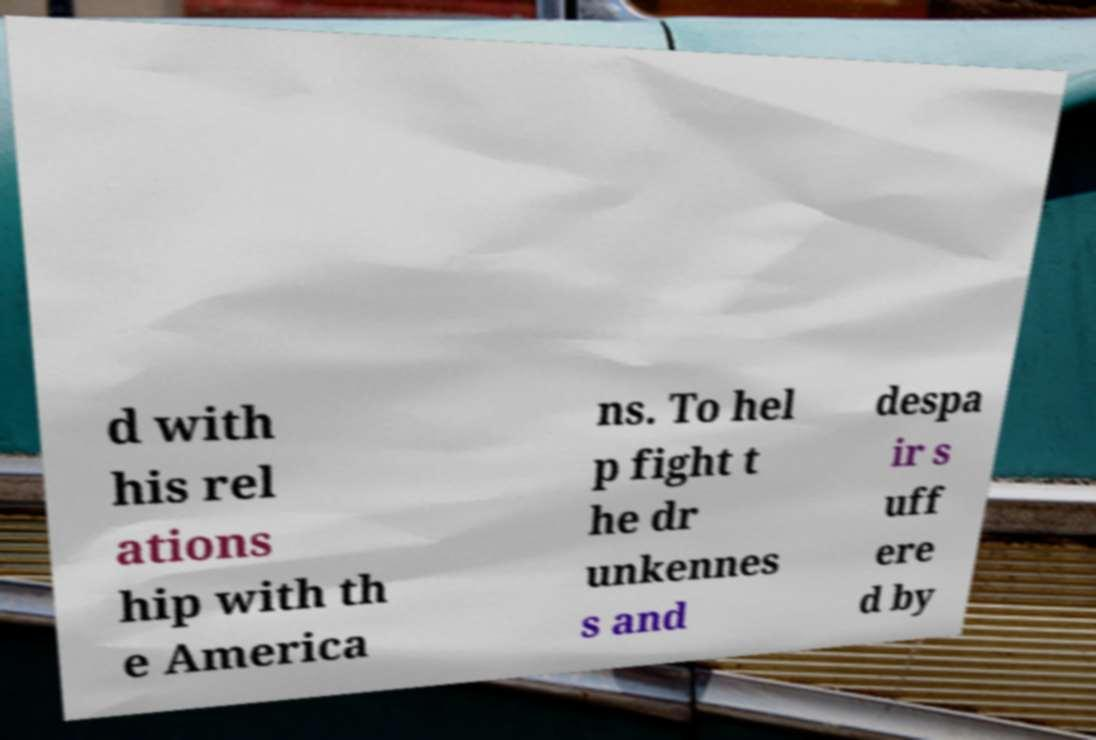Please read and relay the text visible in this image. What does it say? d with his rel ations hip with th e America ns. To hel p fight t he dr unkennes s and despa ir s uff ere d by 